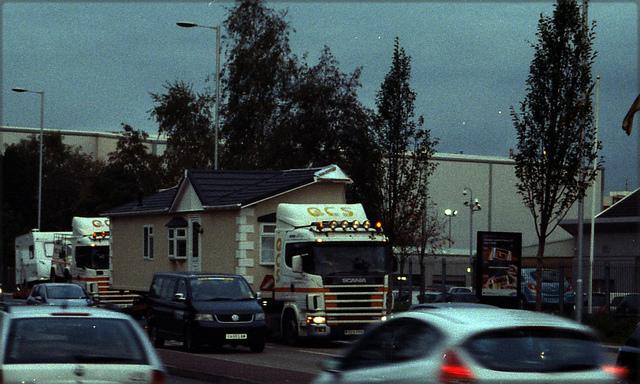What letters are on the truck?
Keep it brief. Qcs. Is this a busy street?
Give a very brief answer. Yes. Is it a sunny day?
Answer briefly. No. Are there palm trees in this area?
Be succinct. No. Can half a house be raised, loaded and change locations?
Answer briefly. Yes. Was the picture taken during the daytime?
Give a very brief answer. Yes. Is this headlight on?
Short answer required. Yes. What color is the awning?
Answer briefly. White. Is it going to rain?
Write a very short answer. Yes. Are there apartments in the background?
Short answer required. No. 